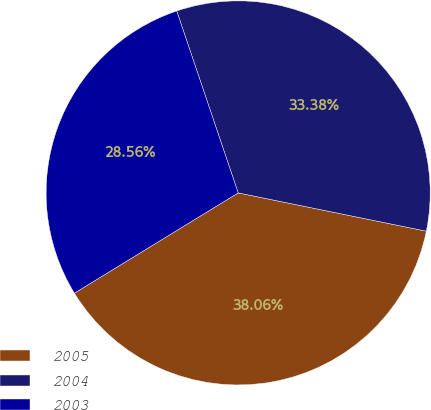<chart> <loc_0><loc_0><loc_500><loc_500><pie_chart><fcel>2005<fcel>2004<fcel>2003<nl><fcel>38.06%<fcel>33.38%<fcel>28.56%<nl></chart> 